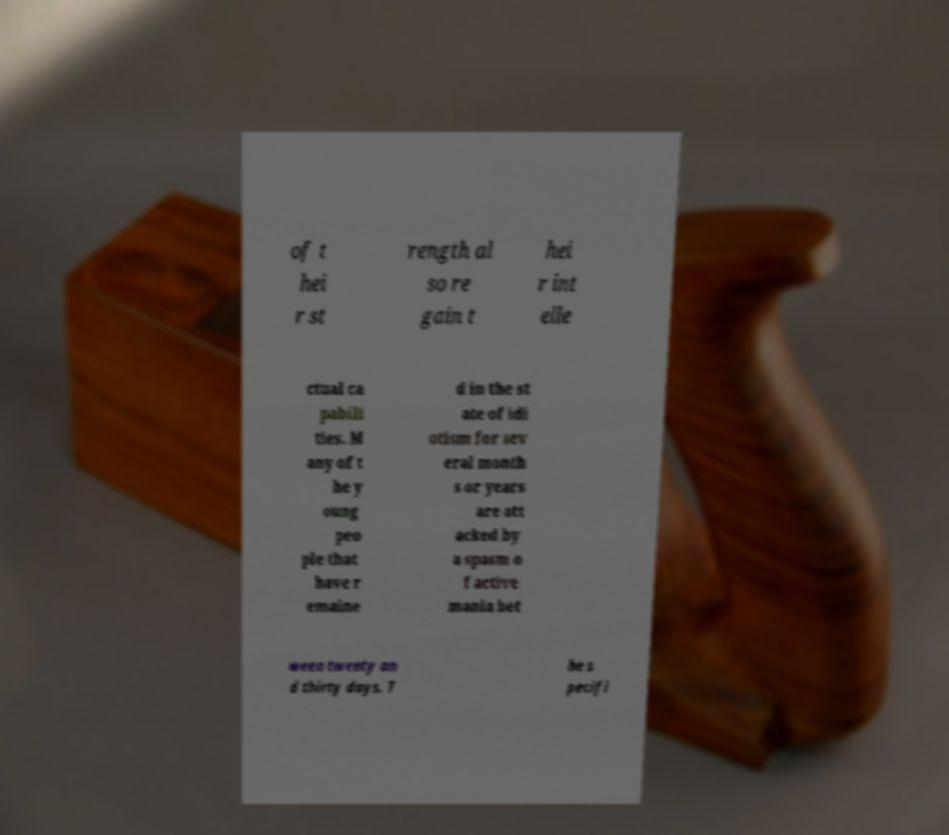For documentation purposes, I need the text within this image transcribed. Could you provide that? of t hei r st rength al so re gain t hei r int elle ctual ca pabili ties. M any of t he y oung peo ple that have r emaine d in the st ate of idi otism for sev eral month s or years are att acked by a spasm o f active mania bet ween twenty an d thirty days. T he s pecifi 